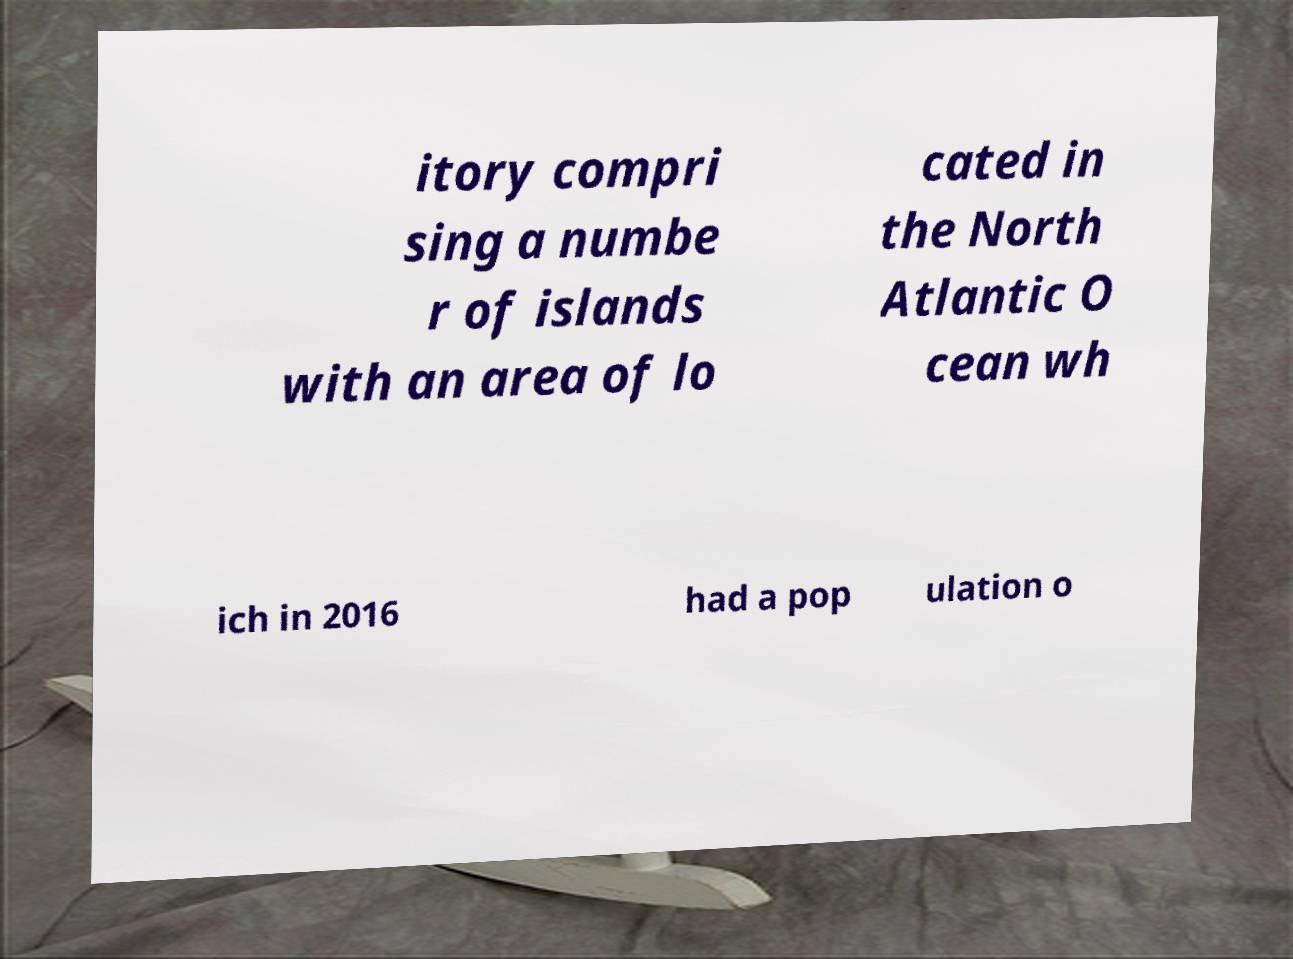I need the written content from this picture converted into text. Can you do that? itory compri sing a numbe r of islands with an area of lo cated in the North Atlantic O cean wh ich in 2016 had a pop ulation o 